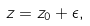<formula> <loc_0><loc_0><loc_500><loc_500>z = z _ { 0 } + \epsilon ,</formula> 